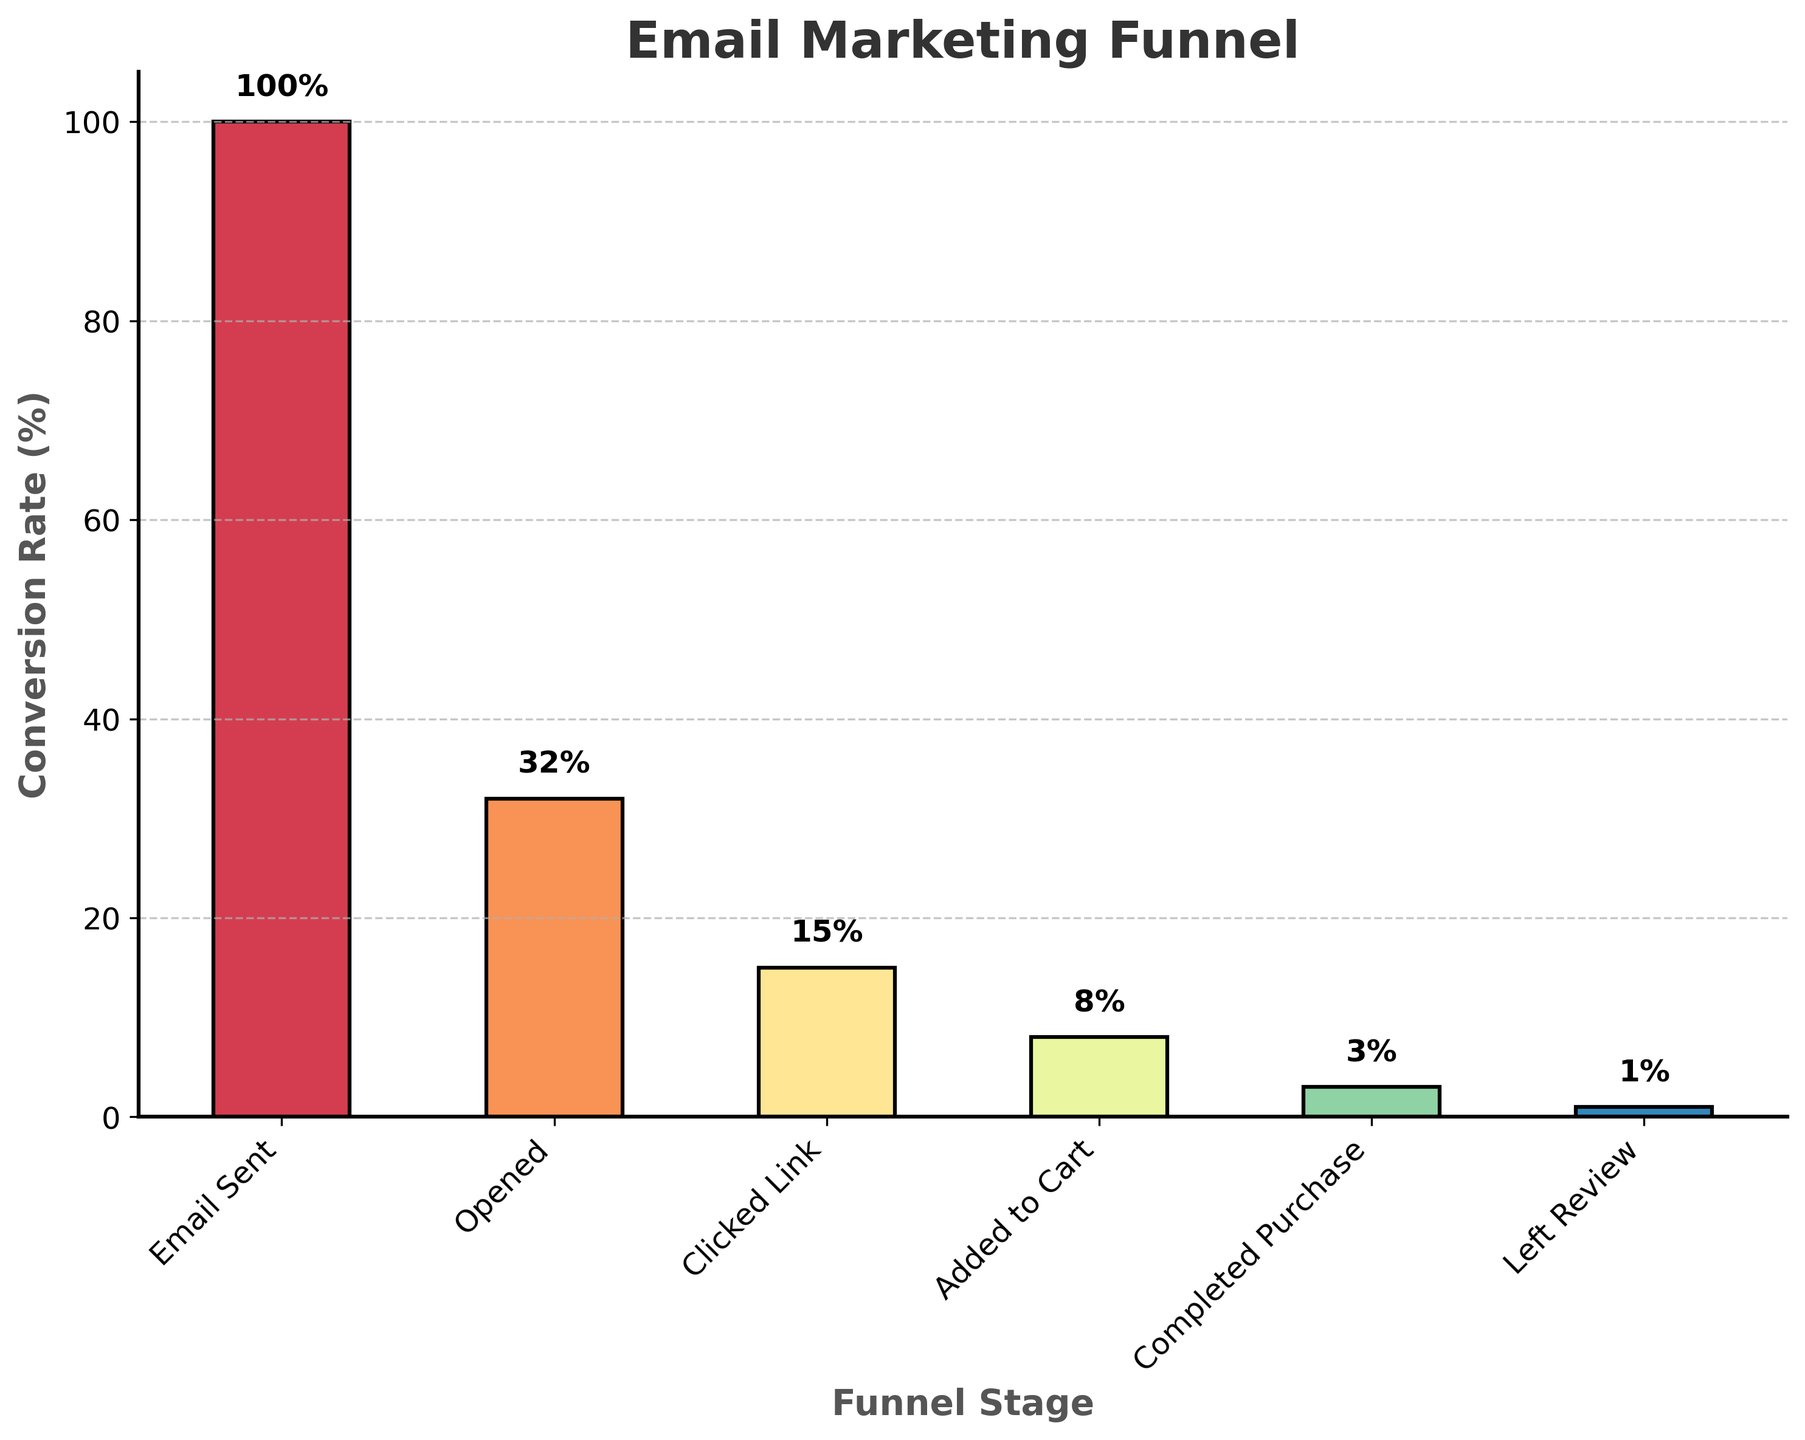What's the title of the figure? The title of the figure is located at the top, usually in a large and bold font. The figure's title is "Email Marketing Funnel".
Answer: Email Marketing Funnel How many stages are depicted in the funnel chart? To determine the number of stages, count the bars on the x-axis. Each bar represents a stage in the funnel chart.
Answer: 6 What is the conversion rate at the 'Clicked Link' stage? Find the bar labeled 'Clicked Link' on the x-axis and check the y-axis value. The conversion rate is displayed above the bar.
Answer: 15% Which stage has the lowest conversion rate? Compare the heights of all the bars. The shortest bar indicates the lowest conversion rate stage.
Answer: Left Review What is the difference in conversion rate between 'Opened' and 'Added to Cart'? First, find the conversion rates for 'Opened' and 'Added to Cart' stages. 'Opened' has a conversion rate of 32%, and 'Added to Cart' has a conversion rate of 8%. Subtract 8% from 32%.
Answer: 24% What percentage of emails sent resulted in a completed purchase? Find the conversion rate of the 'Completed Purchase' stage and refer to the 'Email Sent' stage as the 100%. The 'Completed Purchase' rate is 3%.
Answer: 3% By what factor does the conversion rate decrease from the 'Email Sent' stage to the 'Opened' stage? To find the factor of decrease, divide the 'Email Sent' conversion rate by the 'Opened' conversion rate. The calculation is 100% / 32%.
Answer: Approximately 3.125 Which stage shows the greatest drop in conversion rate from the previous stage? Find the differences between consecutive stages' conversion rates and determine the largest drop. The differences are: Opened to Clicked Link (32% - 15% = 17%), and Clicked Link to Added to Cart (15% - 8% = 7%). The largest drop is 17% between Opened and Clicked Link.
Answer: Opened to Clicked Link What is the average conversion rate from 'Opened' to 'Left Review'? To find the average, sum the conversion rates from 'Opened' to 'Left Review' and divide by the number of stages. The conversion rates are 32%, 15%, 8%, 3%, and 1%. The sum is 59%, and there are 5 stages. The average is 59% / 5.
Answer: 11.8% How is the y-axis labeled? The y-axis label can be found along the vertical axis of the chart. It indicates what is being measured in percentages. The y-axis is labeled 'Conversion Rate (%)'.
Answer: Conversion Rate (%) 